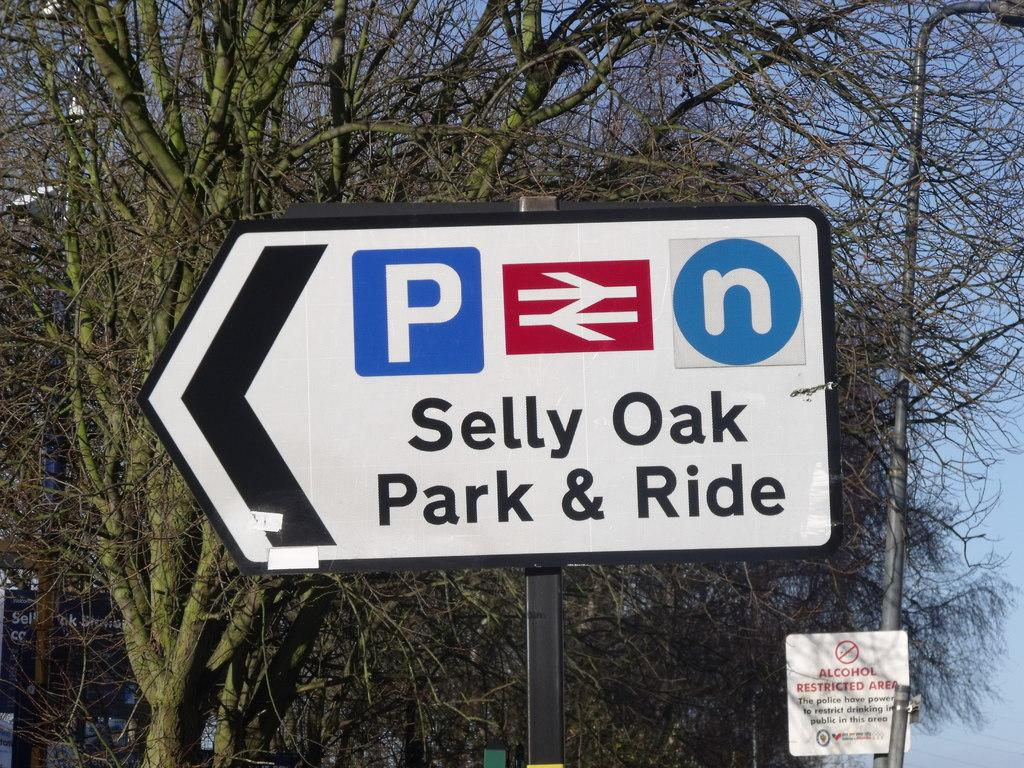<image>
Render a clear and concise summary of the photo. a selly oak sign that is near trees 